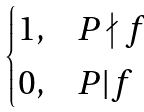Convert formula to latex. <formula><loc_0><loc_0><loc_500><loc_500>\begin{cases} 1 , & P \nmid f \\ 0 , & P | f \end{cases}</formula> 